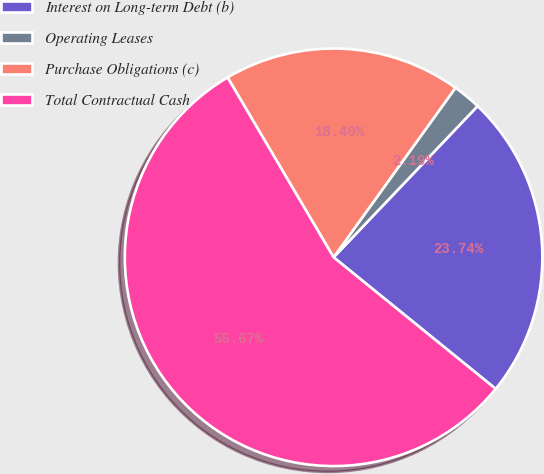<chart> <loc_0><loc_0><loc_500><loc_500><pie_chart><fcel>Interest on Long-term Debt (b)<fcel>Operating Leases<fcel>Purchase Obligations (c)<fcel>Total Contractual Cash<nl><fcel>23.74%<fcel>2.19%<fcel>18.4%<fcel>55.67%<nl></chart> 